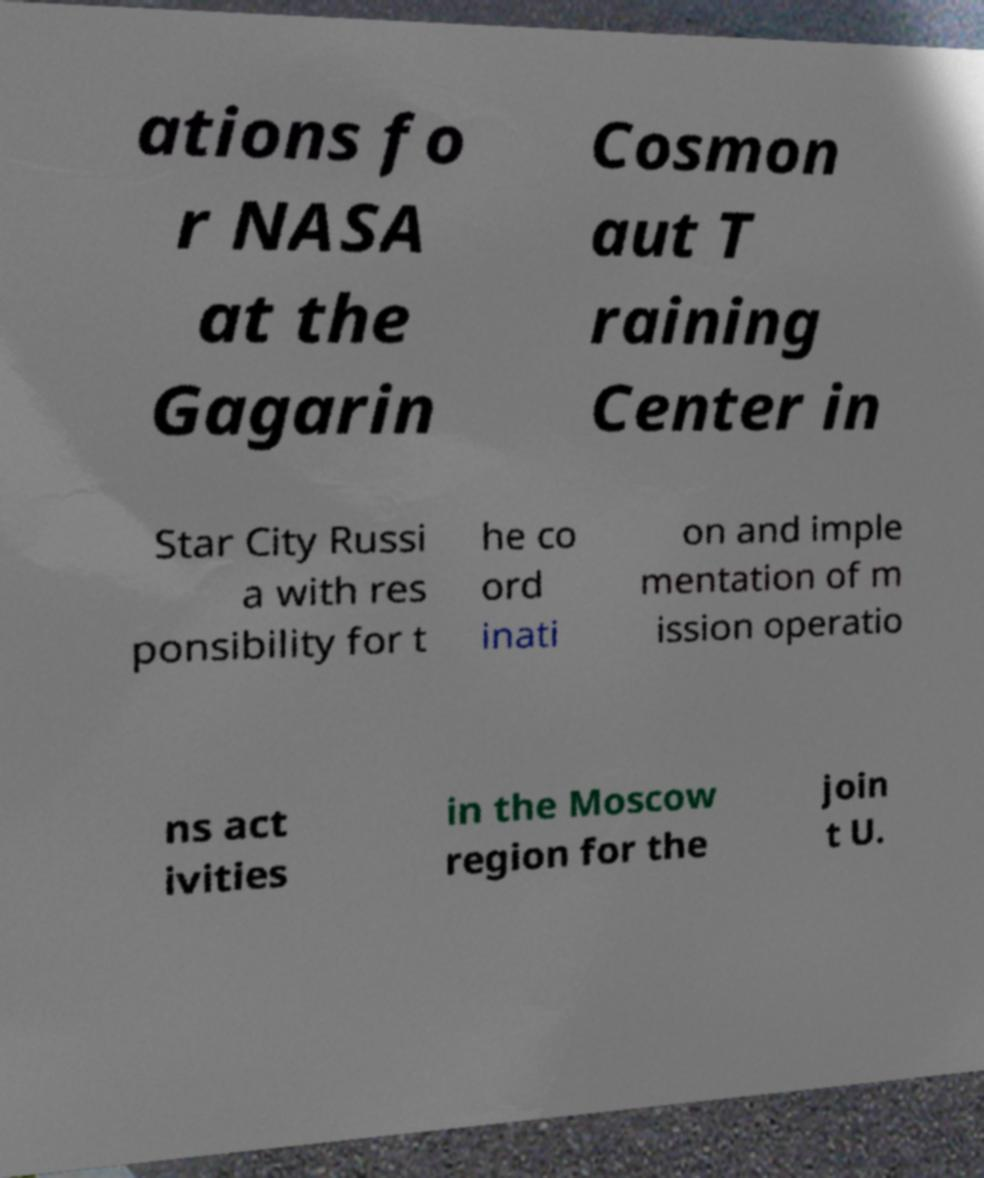Please identify and transcribe the text found in this image. ations fo r NASA at the Gagarin Cosmon aut T raining Center in Star City Russi a with res ponsibility for t he co ord inati on and imple mentation of m ission operatio ns act ivities in the Moscow region for the join t U. 